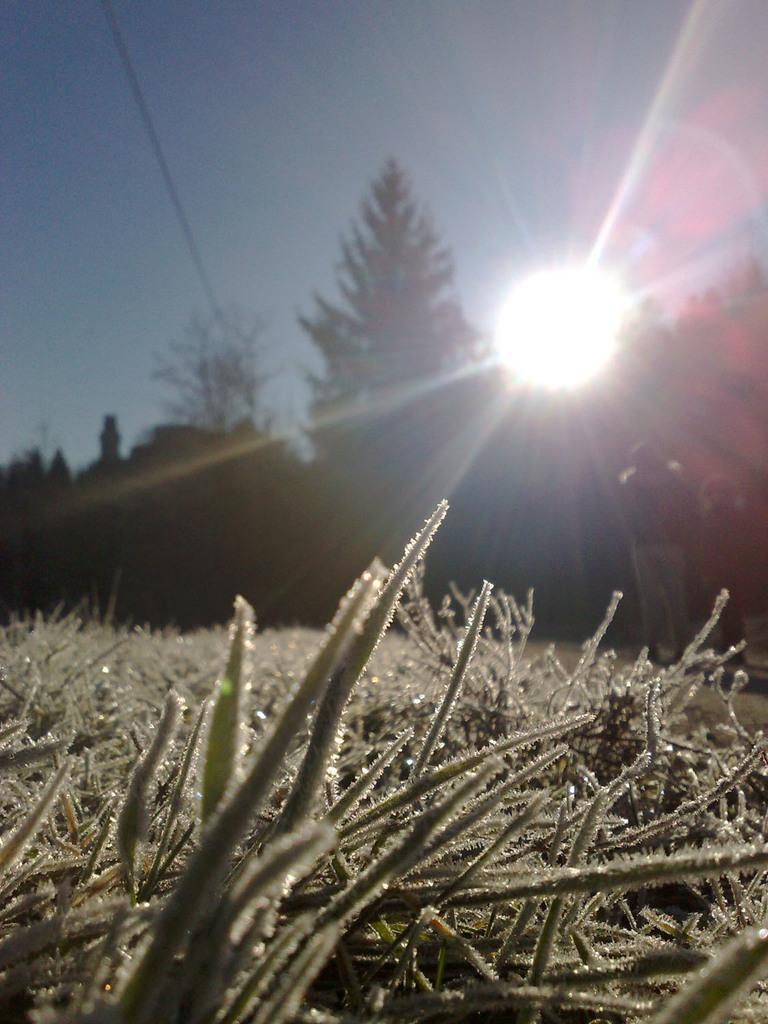In one or two sentences, can you explain what this image depicts? In this image we can see some plants and in the background of the image there are some persons standing near the trees there is clear sky and sunrise. 